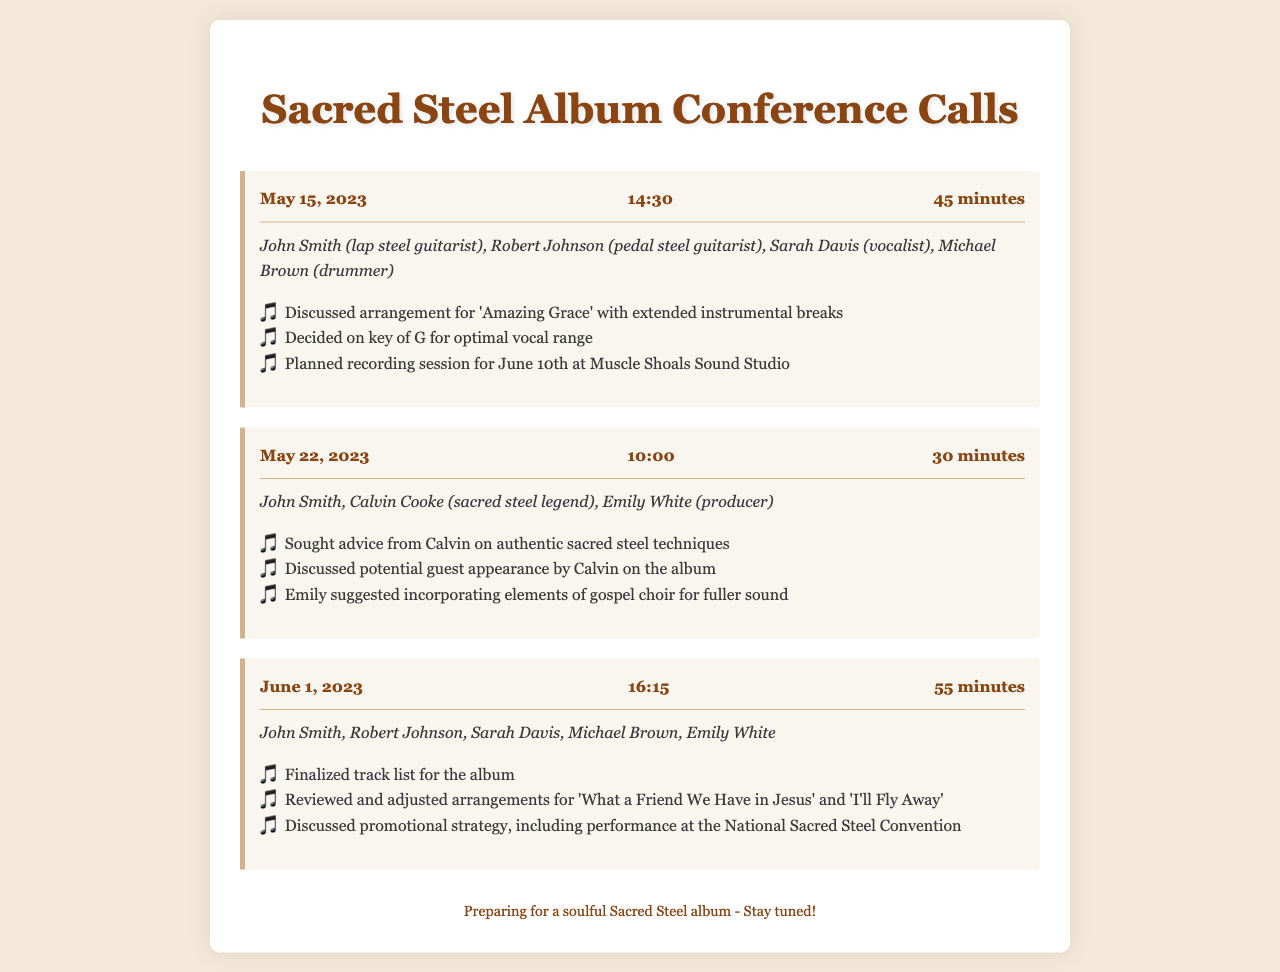What is the date of the first call? The first call took place on May 15, 2023, as seen in the call record header.
Answer: May 15, 2023 Who is a participant in the May 22, 2023 call? The document lists participants for each call, showing that Calvin Cooke is present in the May 22 call.
Answer: Calvin Cooke What is the duration of the call on June 1, 2023? The call on June 1, 2023 lasted for 55 minutes, as indicated in the call duration section.
Answer: 55 minutes Which song was arranged in the first call? The document states that 'Amazing Grace' was discussed in the first call for arrangements.
Answer: Amazing Grace What was a key suggestion made by Emily White during the May 22 call? Emily suggested incorporating elements of gospel choir for a fuller sound in the discussion.
Answer: Incorporating elements of gospel choir How many participants were in the June 1, 2023 call? The document lists five participants present in the June 1 call.
Answer: Five What song's arrangement was reviewed on June 1? The songs 'What a Friend We Have in Jesus' and 'I'll Fly Away' were reviewed for arrangements.
Answer: What a Friend We Have in Jesus and I'll Fly Away When is the planned recording session? The document states that the recording session is planned for June 10th.
Answer: June 10th What is the main topic discussed in the first call? The main topic of the first call was the arrangement of 'Amazing Grace' with extended instrumental breaks.
Answer: Arrangement of 'Amazing Grace' 